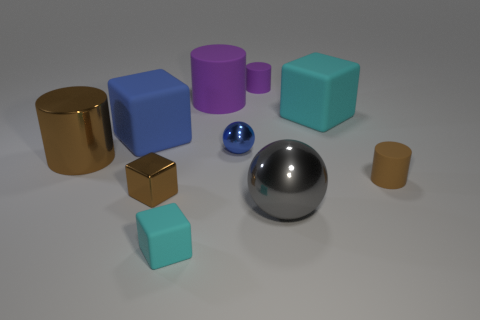How would you group these objects based on their shapes? We can group the objects by their geometric shapes. There are four cubes, two cylinders, and two spheres. The cubes and cylinders illustrate variations in proportions and size, while the two spheres offer a comparison between sizes and surface properties, one being much shinier than the other. 